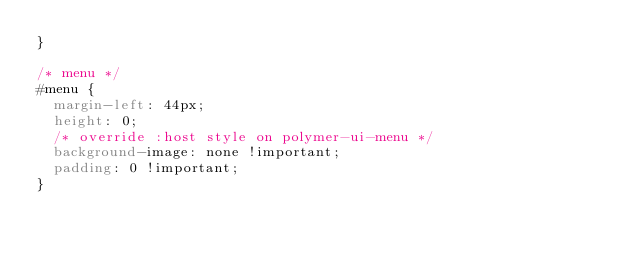Convert code to text. <code><loc_0><loc_0><loc_500><loc_500><_CSS_>}

/* menu */
#menu {
  margin-left: 44px;
  height: 0;
  /* override :host style on polymer-ui-menu */
  background-image: none !important;
  padding: 0 !important;
}
</code> 